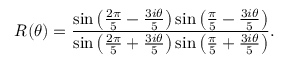<formula> <loc_0><loc_0><loc_500><loc_500>R ( \theta ) = \frac { \sin \left ( \frac { 2 \pi } { 5 } - \frac { 3 i \theta } { 5 } \right ) \sin \left ( \frac { \pi } { 5 } - \frac { 3 i \theta } { 5 } \right ) } { \sin \left ( \frac { 2 \pi } { 5 } + \frac { 3 i \theta } { 5 } \right ) \sin \left ( \frac { \pi } { 5 } + \frac { 3 i \theta } { 5 } \right ) } .</formula> 